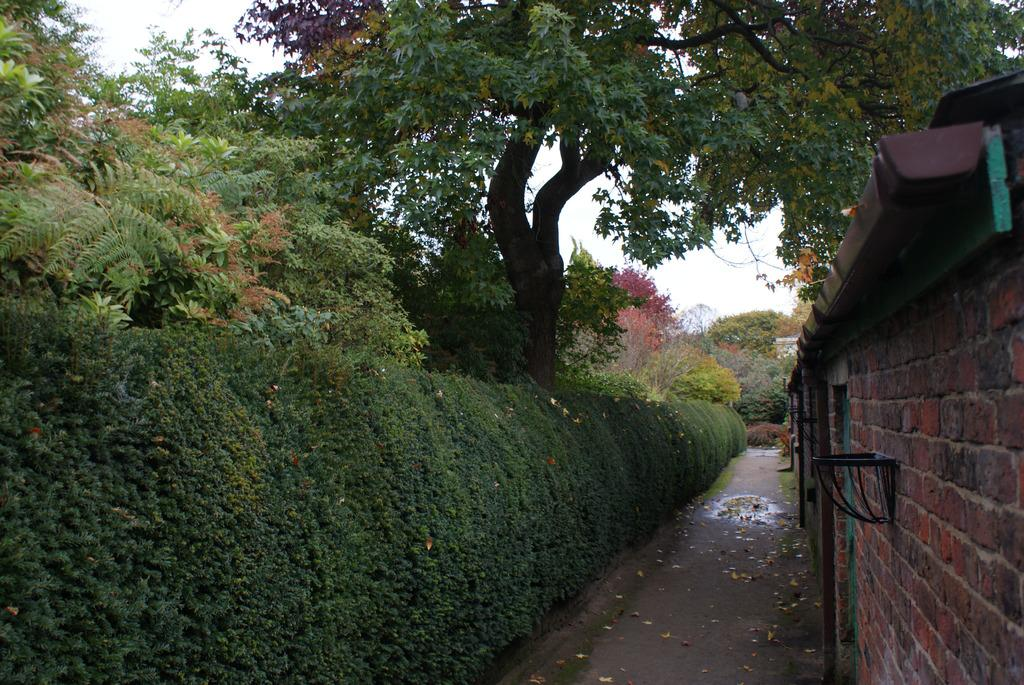What type of structures can be seen in the image? There are houses in the image. What is attached to the houses? There are objects attached to the houses. What can be used for walking or traveling in the image? There is a path in the image. What type of vegetation is present in the image? There are plants and trees in the image. What is visible at the top of the image? The sky is visible in the image. What type of coat is the creature wearing in the image? There is no creature present in the image, and therefore no coat can be observed. 